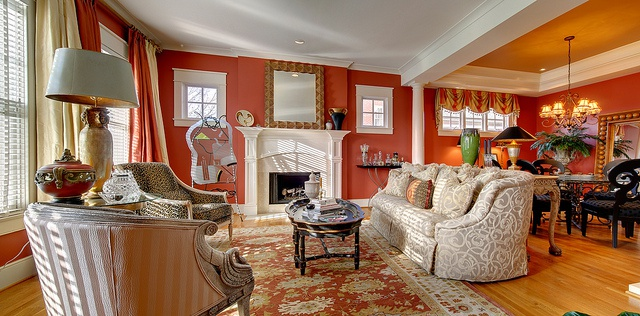Describe the objects in this image and their specific colors. I can see chair in darkgray, maroon, gray, and brown tones, couch in darkgray, maroon, gray, and brown tones, couch in darkgray, gray, lightgray, and tan tones, chair in darkgray, maroon, black, and gray tones, and couch in darkgray, maroon, black, and gray tones in this image. 